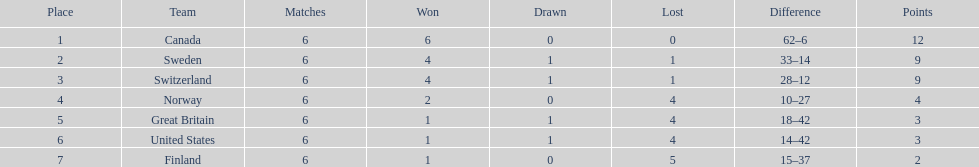For the 1951 world ice hockey championships, what was the disparity in games won between the team that finished first and the team that finished last? 5. 